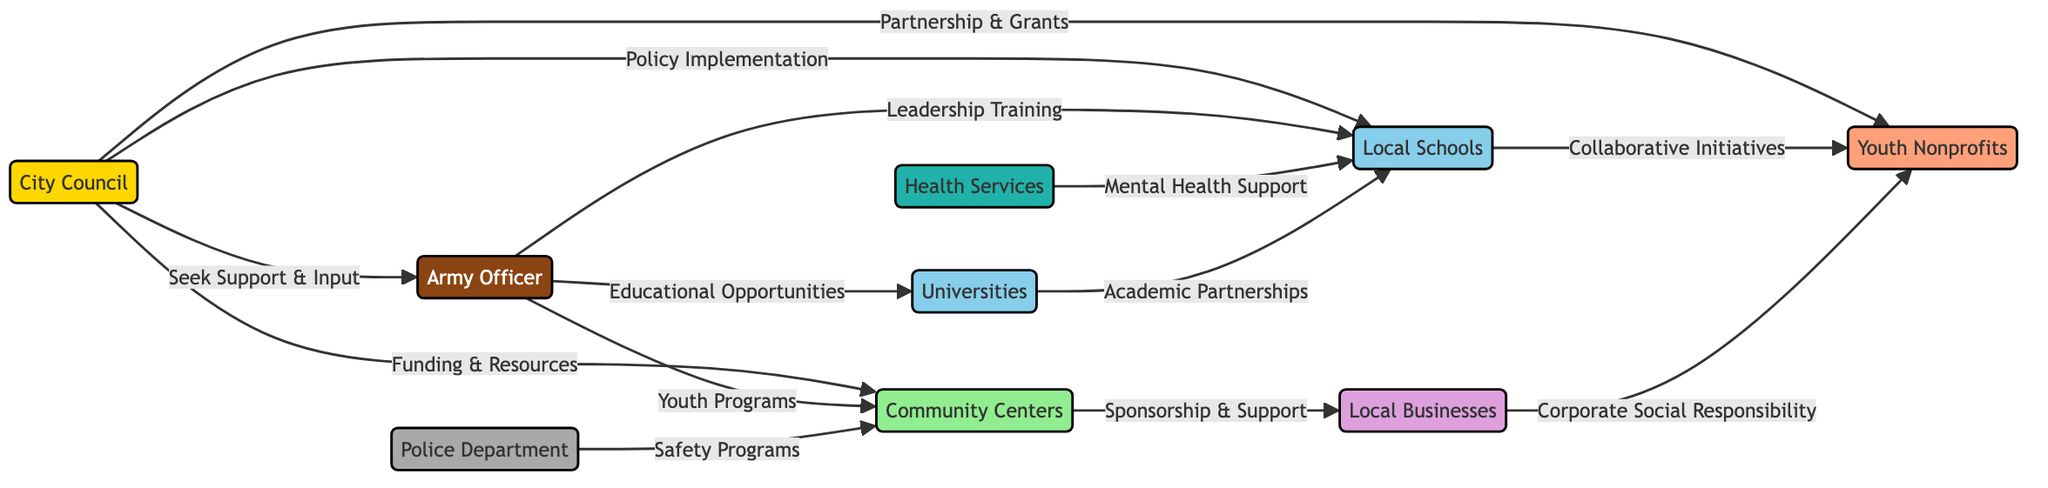What is the total number of nodes in the diagram? The diagram lists 9 distinct entities as nodes: City Council, Army Officer, Local Schools, Community Centers, Youth Nonprofits, Local Businesses, Police Department, Universities, and Health Services. Thus, by counting each listed node, we find that the total is 9.
Answer: 9 Which nodes does the City Council directly connect to? The City Council connects to four specific nodes: Army Officer, Local Schools, Community Centers, and Youth Nonprofits. Each of these connections is represented by arrows from the City Council to these four entities, indicating direct relationships.
Answer: Army Officer, Local Schools, Community Centers, Youth Nonprofits What is the relationship between the Army Officer and Local Schools? The Army Officer has a direct relationship with Local Schools, labeled as "Leadership Training". This implies that the Army Officer supports or provides leadership training specifically targeted at this educational entity.
Answer: Leadership Training How many connections are there between Local Schools and other nodes? Local Schools have three outgoing connections: to Army Officer (not direct), to Youth Nonprofits through collaborative initiatives, and to Health Services for mental health support. Moreover, it receives input from Universities as well. Therefore, the total connections for Local Schools is four.
Answer: 4 What kind of support do Community Centers receive from Local Businesses? The diagram indicates that Community Centers receive support from Local Businesses through "Sponsorship & Support." This shows a direct interaction where Local Businesses contribute sponsorship, likely in financial or resource terms to Community Centers.
Answer: Sponsorship & Support Which entity provides educational opportunities related to the Army Officer? The Army Officer has a direct connection to Universities, labeled "Educational Opportunities." This indicates that the Army Officer plays a role in providing or facilitating educational options through their relationship with universities.
Answer: Universities How many types of entities are represented in the diagram? The diagram includes seven distinct types of entities: government, military, education, community, nonprofit, business, security, and healthcare. Each type indicates a different role or sector relevant to the youth leadership and training programs ecosystem.
Answer: 8 What is the flow of support from Health Services to Local Schools? Health Services provide support to Local Schools via "Mental Health Support," indicating that the Health Services entity is connected to Local Schools with the aim of delivering mental health resources or programs. This relationship shows a focused contribution from healthcare to the education sector.
Answer: Mental Health Support 